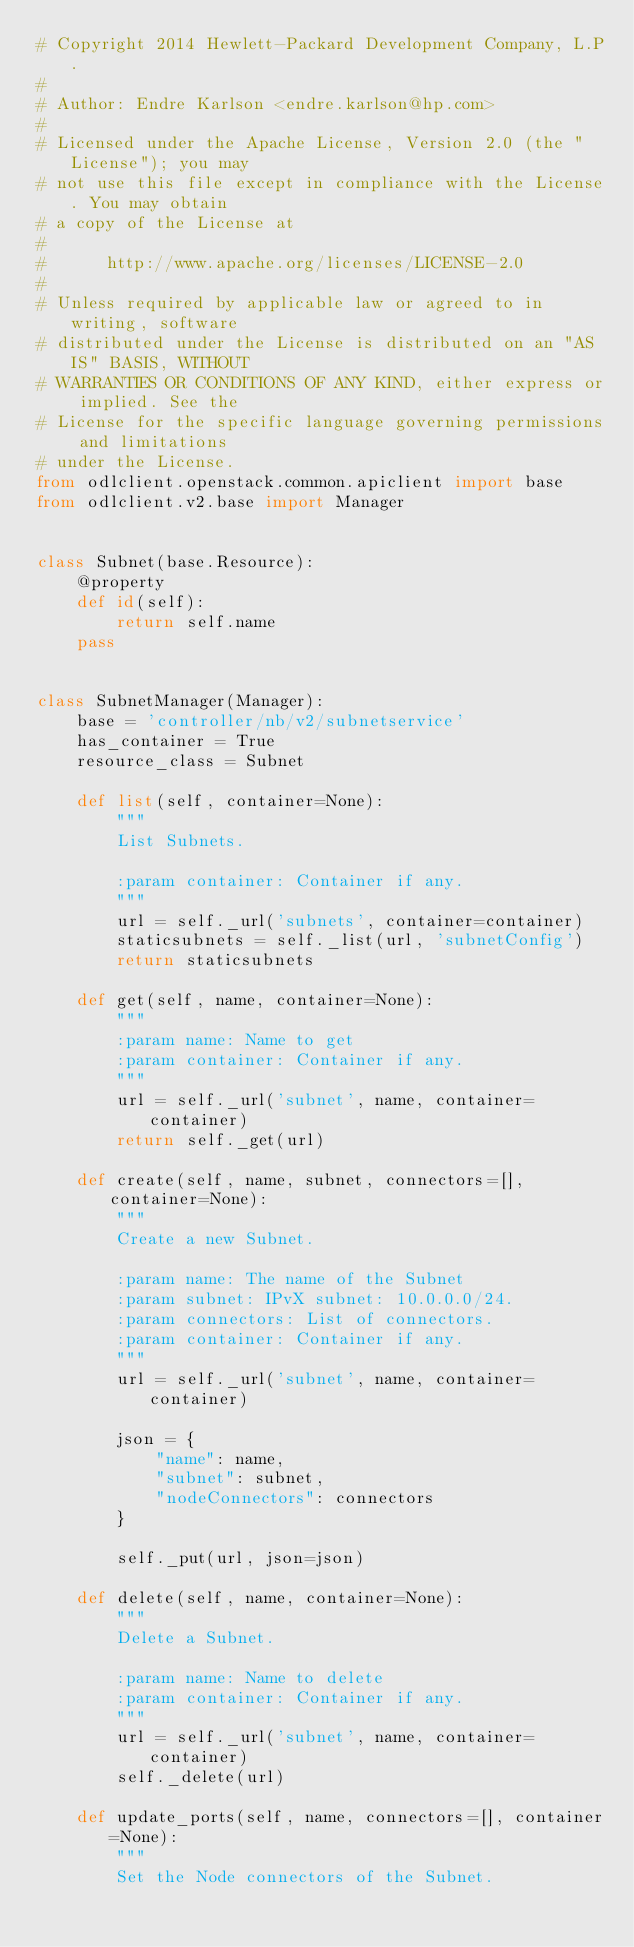Convert code to text. <code><loc_0><loc_0><loc_500><loc_500><_Python_># Copyright 2014 Hewlett-Packard Development Company, L.P.
#
# Author: Endre Karlson <endre.karlson@hp.com>
#
# Licensed under the Apache License, Version 2.0 (the "License"); you may
# not use this file except in compliance with the License. You may obtain
# a copy of the License at
#
#      http://www.apache.org/licenses/LICENSE-2.0
#
# Unless required by applicable law or agreed to in writing, software
# distributed under the License is distributed on an "AS IS" BASIS, WITHOUT
# WARRANTIES OR CONDITIONS OF ANY KIND, either express or implied. See the
# License for the specific language governing permissions and limitations
# under the License.
from odlclient.openstack.common.apiclient import base
from odlclient.v2.base import Manager


class Subnet(base.Resource):
    @property
    def id(self):
        return self.name
    pass


class SubnetManager(Manager):
    base = 'controller/nb/v2/subnetservice'
    has_container = True
    resource_class = Subnet

    def list(self, container=None):
        """
        List Subnets.

        :param container: Container if any.
        """
        url = self._url('subnets', container=container)
        staticsubnets = self._list(url, 'subnetConfig')
        return staticsubnets

    def get(self, name, container=None):
        """
        :param name: Name to get
        :param container: Container if any.
        """
        url = self._url('subnet', name, container=container)
        return self._get(url)

    def create(self, name, subnet, connectors=[], container=None):
        """
        Create a new Subnet.

        :param name: The name of the Subnet
        :param subnet: IPvX subnet: 10.0.0.0/24.
        :param connectors: List of connectors.
        :param container: Container if any.
        """
        url = self._url('subnet', name, container=container)

        json = {
            "name": name,
            "subnet": subnet,
            "nodeConnectors": connectors
        }

        self._put(url, json=json)

    def delete(self, name, container=None):
        """
        Delete a Subnet.

        :param name: Name to delete
        :param container: Container if any.
        """
        url = self._url('subnet', name, container=container)
        self._delete(url)

    def update_ports(self, name, connectors=[], container=None):
        """
        Set the Node connectors of the Subnet.
</code> 